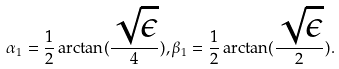<formula> <loc_0><loc_0><loc_500><loc_500>\alpha _ { 1 } = \frac { 1 } { 2 } \arctan ( \frac { \sqrt { \epsilon } } { 4 } ) , \beta _ { 1 } = \frac { 1 } { 2 } \arctan ( \frac { \sqrt { \epsilon } } { 2 } ) .</formula> 